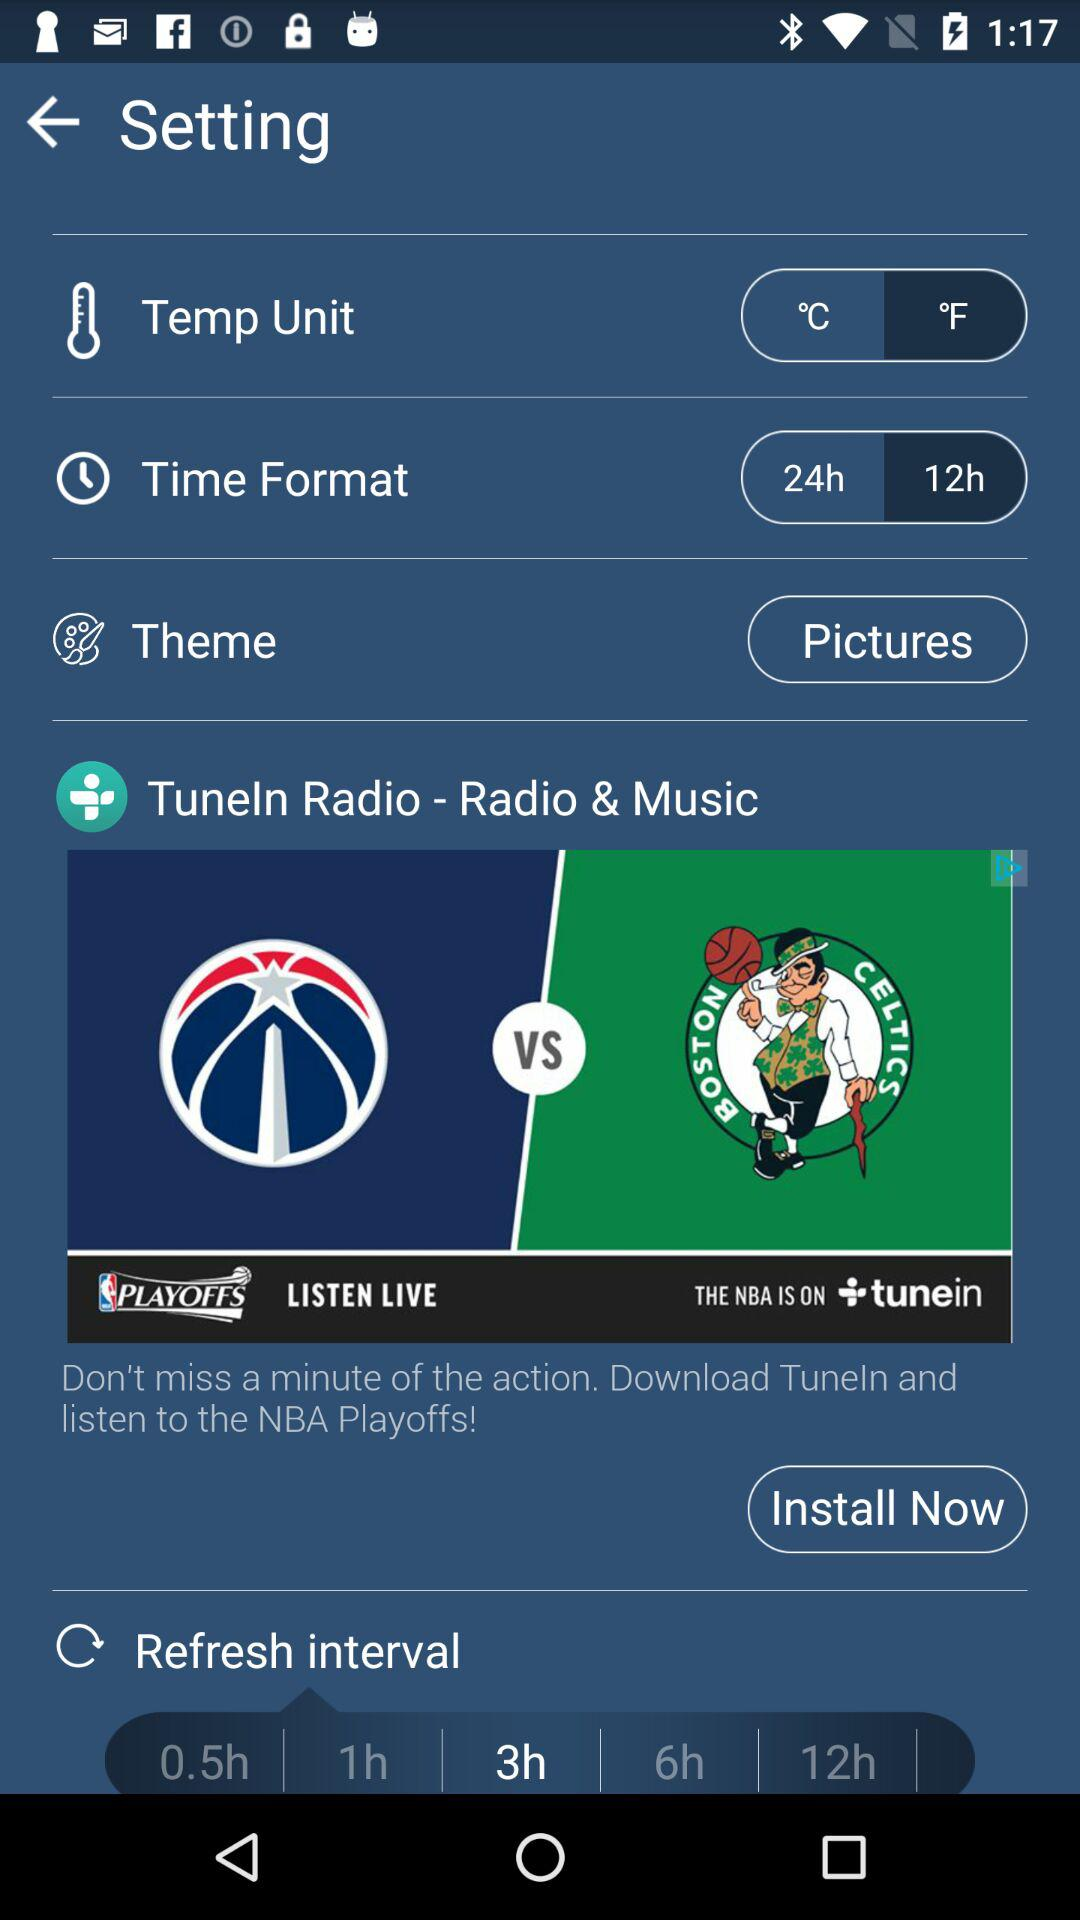What are the options available for the refresh interval? The available options are "0.5h", "1h", "3h", "6h" and "12h". 